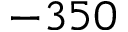Convert formula to latex. <formula><loc_0><loc_0><loc_500><loc_500>- 3 5 0</formula> 